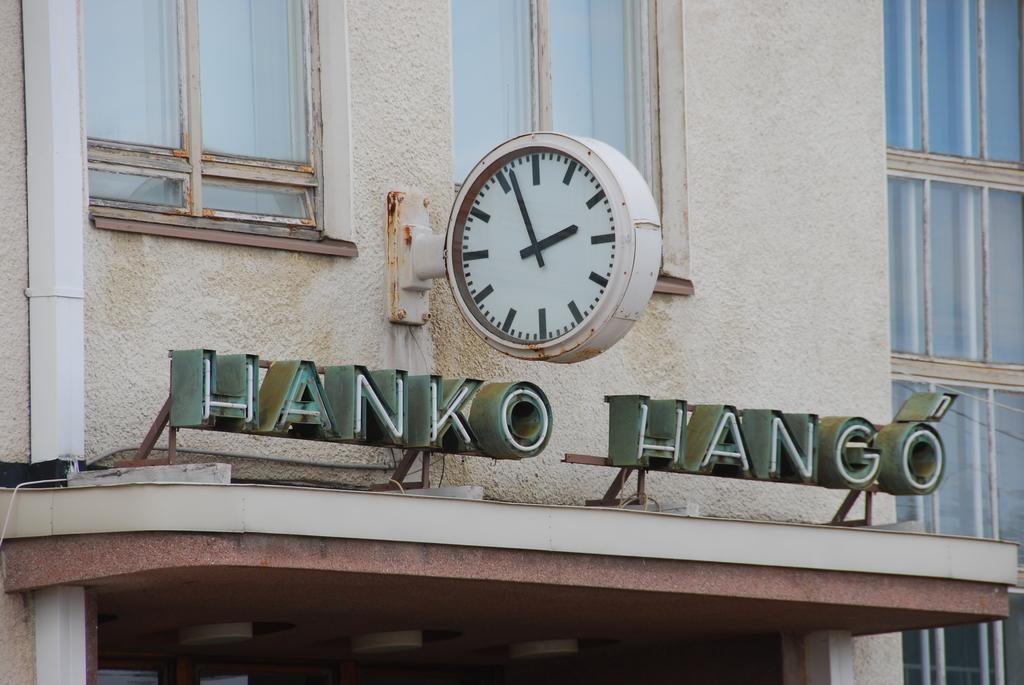<image>
Create a compact narrative representing the image presented. a hanko hango sign that is above some kind of complex 